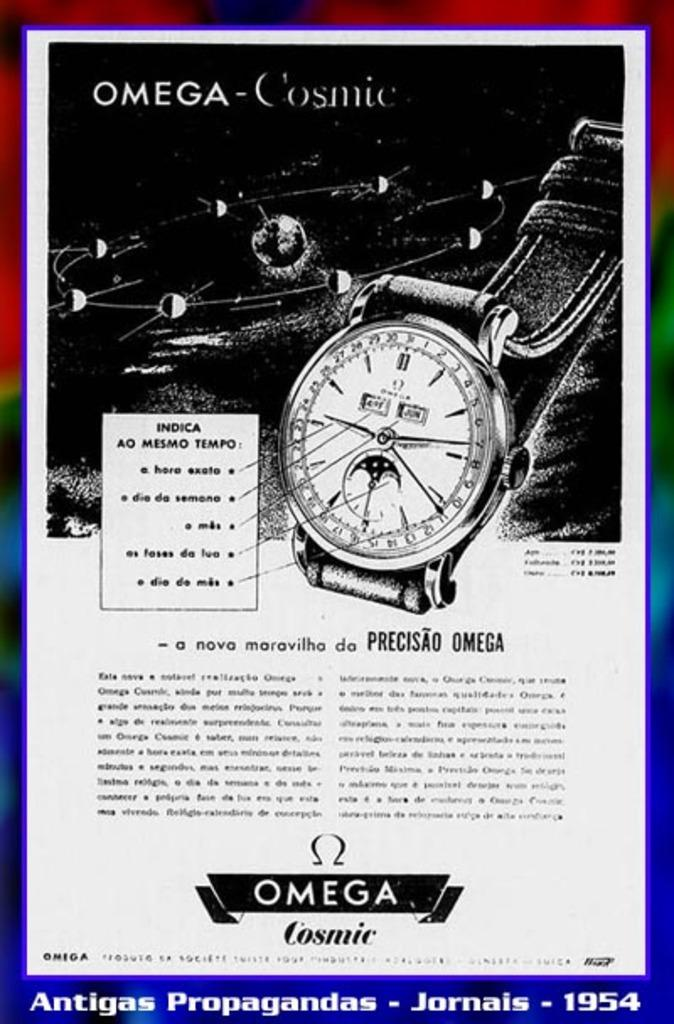<image>
Give a short and clear explanation of the subsequent image. An Omega advertisement features a watch and some planets. 